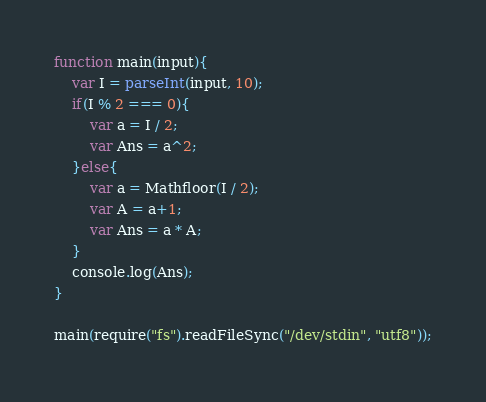Convert code to text. <code><loc_0><loc_0><loc_500><loc_500><_JavaScript_>function main(input){
	var I = parseInt(input, 10);
	if(I % 2 === 0){
		var a = I / 2;
      	var Ans = a^2;
    }else{
		var a = Mathfloor(I / 2);
      	var A = a+1;
      	var Ans = a * A;
    }
  	console.log(Ans);
}

main(require("fs").readFileSync("/dev/stdin", "utf8"));</code> 